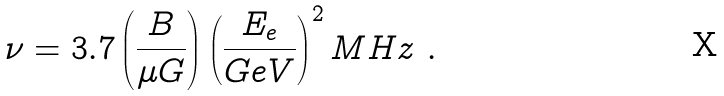Convert formula to latex. <formula><loc_0><loc_0><loc_500><loc_500>\nu = 3 . 7 \left ( \frac { B } { \mu G } \right ) \left ( \frac { E _ { e } } { G e V } \right ) ^ { 2 } M H z \ .</formula> 